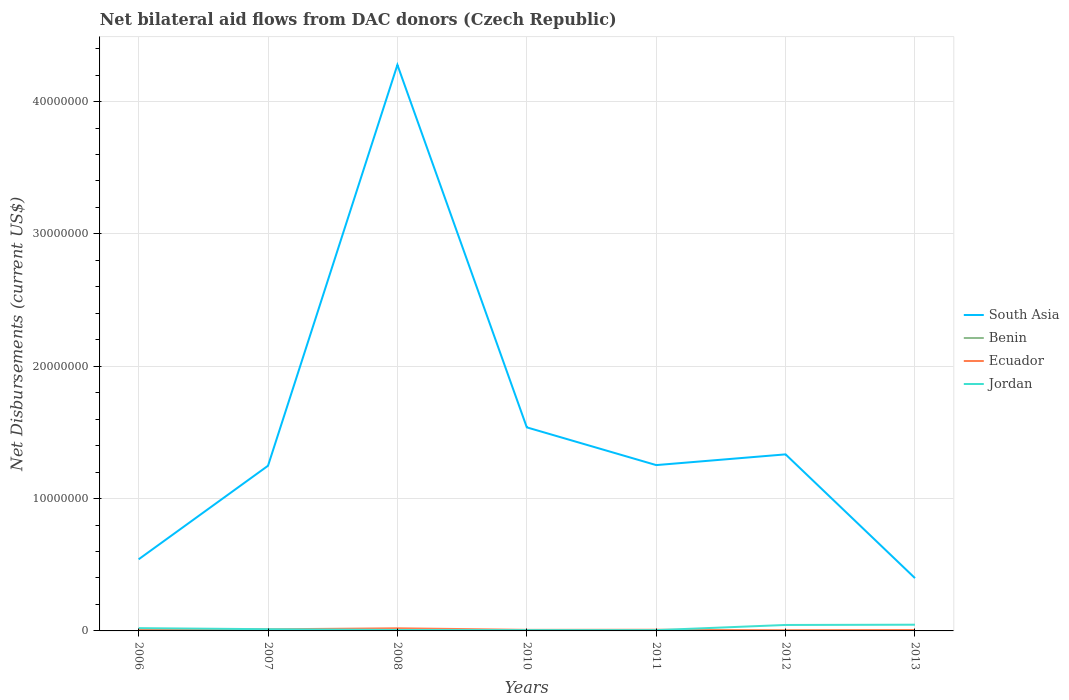Is the number of lines equal to the number of legend labels?
Keep it short and to the point. Yes. Across all years, what is the maximum net bilateral aid flows in Jordan?
Keep it short and to the point. 6.00e+04. In which year was the net bilateral aid flows in South Asia maximum?
Your response must be concise. 2013. What is the total net bilateral aid flows in South Asia in the graph?
Your answer should be compact. -9.97e+06. Is the net bilateral aid flows in South Asia strictly greater than the net bilateral aid flows in Ecuador over the years?
Provide a short and direct response. No. How many years are there in the graph?
Offer a terse response. 7. Where does the legend appear in the graph?
Give a very brief answer. Center right. How are the legend labels stacked?
Give a very brief answer. Vertical. What is the title of the graph?
Your answer should be compact. Net bilateral aid flows from DAC donors (Czech Republic). Does "Madagascar" appear as one of the legend labels in the graph?
Give a very brief answer. No. What is the label or title of the X-axis?
Your answer should be very brief. Years. What is the label or title of the Y-axis?
Offer a very short reply. Net Disbursements (current US$). What is the Net Disbursements (current US$) of South Asia in 2006?
Offer a terse response. 5.41e+06. What is the Net Disbursements (current US$) in Benin in 2006?
Keep it short and to the point. 10000. What is the Net Disbursements (current US$) in South Asia in 2007?
Provide a short and direct response. 1.25e+07. What is the Net Disbursements (current US$) of Benin in 2007?
Give a very brief answer. 10000. What is the Net Disbursements (current US$) in Jordan in 2007?
Offer a terse response. 1.30e+05. What is the Net Disbursements (current US$) in South Asia in 2008?
Give a very brief answer. 4.28e+07. What is the Net Disbursements (current US$) in Benin in 2008?
Your response must be concise. 4.00e+04. What is the Net Disbursements (current US$) of Ecuador in 2008?
Your answer should be compact. 2.00e+05. What is the Net Disbursements (current US$) in Jordan in 2008?
Your answer should be very brief. 7.00e+04. What is the Net Disbursements (current US$) of South Asia in 2010?
Provide a succinct answer. 1.54e+07. What is the Net Disbursements (current US$) of Ecuador in 2010?
Your answer should be compact. 8.00e+04. What is the Net Disbursements (current US$) in South Asia in 2011?
Your answer should be very brief. 1.25e+07. What is the Net Disbursements (current US$) in Benin in 2011?
Make the answer very short. 2.00e+04. What is the Net Disbursements (current US$) in South Asia in 2012?
Your answer should be very brief. 1.33e+07. What is the Net Disbursements (current US$) of Benin in 2012?
Your answer should be compact. 2.00e+04. What is the Net Disbursements (current US$) in Jordan in 2012?
Your response must be concise. 4.50e+05. What is the Net Disbursements (current US$) in South Asia in 2013?
Your answer should be compact. 3.99e+06. What is the Net Disbursements (current US$) in Benin in 2013?
Give a very brief answer. 3.00e+04. What is the Net Disbursements (current US$) in Jordan in 2013?
Give a very brief answer. 4.70e+05. Across all years, what is the maximum Net Disbursements (current US$) of South Asia?
Keep it short and to the point. 4.28e+07. Across all years, what is the maximum Net Disbursements (current US$) of Ecuador?
Provide a succinct answer. 2.00e+05. Across all years, what is the minimum Net Disbursements (current US$) of South Asia?
Make the answer very short. 3.99e+06. Across all years, what is the minimum Net Disbursements (current US$) of Ecuador?
Offer a very short reply. 5.00e+04. What is the total Net Disbursements (current US$) in South Asia in the graph?
Ensure brevity in your answer.  1.06e+08. What is the total Net Disbursements (current US$) of Ecuador in the graph?
Your answer should be very brief. 7.20e+05. What is the total Net Disbursements (current US$) in Jordan in the graph?
Keep it short and to the point. 1.45e+06. What is the difference between the Net Disbursements (current US$) in South Asia in 2006 and that in 2007?
Your response must be concise. -7.07e+06. What is the difference between the Net Disbursements (current US$) of South Asia in 2006 and that in 2008?
Your response must be concise. -3.74e+07. What is the difference between the Net Disbursements (current US$) of Benin in 2006 and that in 2008?
Offer a terse response. -3.00e+04. What is the difference between the Net Disbursements (current US$) in Ecuador in 2006 and that in 2008?
Provide a succinct answer. -9.00e+04. What is the difference between the Net Disbursements (current US$) in South Asia in 2006 and that in 2010?
Provide a short and direct response. -9.97e+06. What is the difference between the Net Disbursements (current US$) of Benin in 2006 and that in 2010?
Offer a terse response. -10000. What is the difference between the Net Disbursements (current US$) of Jordan in 2006 and that in 2010?
Give a very brief answer. 1.50e+05. What is the difference between the Net Disbursements (current US$) of South Asia in 2006 and that in 2011?
Ensure brevity in your answer.  -7.12e+06. What is the difference between the Net Disbursements (current US$) of Benin in 2006 and that in 2011?
Provide a short and direct response. -10000. What is the difference between the Net Disbursements (current US$) of Ecuador in 2006 and that in 2011?
Ensure brevity in your answer.  2.00e+04. What is the difference between the Net Disbursements (current US$) of South Asia in 2006 and that in 2012?
Make the answer very short. -7.93e+06. What is the difference between the Net Disbursements (current US$) in Benin in 2006 and that in 2012?
Your answer should be very brief. -10000. What is the difference between the Net Disbursements (current US$) in Jordan in 2006 and that in 2012?
Offer a very short reply. -2.40e+05. What is the difference between the Net Disbursements (current US$) in South Asia in 2006 and that in 2013?
Offer a terse response. 1.42e+06. What is the difference between the Net Disbursements (current US$) in Benin in 2006 and that in 2013?
Provide a succinct answer. -2.00e+04. What is the difference between the Net Disbursements (current US$) in Ecuador in 2006 and that in 2013?
Provide a succinct answer. 4.00e+04. What is the difference between the Net Disbursements (current US$) in South Asia in 2007 and that in 2008?
Your answer should be compact. -3.03e+07. What is the difference between the Net Disbursements (current US$) of Benin in 2007 and that in 2008?
Offer a terse response. -3.00e+04. What is the difference between the Net Disbursements (current US$) in Jordan in 2007 and that in 2008?
Your response must be concise. 6.00e+04. What is the difference between the Net Disbursements (current US$) of South Asia in 2007 and that in 2010?
Ensure brevity in your answer.  -2.90e+06. What is the difference between the Net Disbursements (current US$) in Jordan in 2007 and that in 2010?
Offer a terse response. 7.00e+04. What is the difference between the Net Disbursements (current US$) of Benin in 2007 and that in 2011?
Provide a short and direct response. -10000. What is the difference between the Net Disbursements (current US$) of Ecuador in 2007 and that in 2011?
Offer a very short reply. 3.00e+04. What is the difference between the Net Disbursements (current US$) of South Asia in 2007 and that in 2012?
Keep it short and to the point. -8.60e+05. What is the difference between the Net Disbursements (current US$) in Ecuador in 2007 and that in 2012?
Keep it short and to the point. 7.00e+04. What is the difference between the Net Disbursements (current US$) of Jordan in 2007 and that in 2012?
Provide a succinct answer. -3.20e+05. What is the difference between the Net Disbursements (current US$) of South Asia in 2007 and that in 2013?
Make the answer very short. 8.49e+06. What is the difference between the Net Disbursements (current US$) of South Asia in 2008 and that in 2010?
Provide a succinct answer. 2.74e+07. What is the difference between the Net Disbursements (current US$) in Benin in 2008 and that in 2010?
Ensure brevity in your answer.  2.00e+04. What is the difference between the Net Disbursements (current US$) of Ecuador in 2008 and that in 2010?
Give a very brief answer. 1.20e+05. What is the difference between the Net Disbursements (current US$) of Jordan in 2008 and that in 2010?
Keep it short and to the point. 10000. What is the difference between the Net Disbursements (current US$) of South Asia in 2008 and that in 2011?
Ensure brevity in your answer.  3.02e+07. What is the difference between the Net Disbursements (current US$) in Ecuador in 2008 and that in 2011?
Provide a short and direct response. 1.10e+05. What is the difference between the Net Disbursements (current US$) in South Asia in 2008 and that in 2012?
Give a very brief answer. 2.94e+07. What is the difference between the Net Disbursements (current US$) in Benin in 2008 and that in 2012?
Ensure brevity in your answer.  2.00e+04. What is the difference between the Net Disbursements (current US$) in Ecuador in 2008 and that in 2012?
Keep it short and to the point. 1.50e+05. What is the difference between the Net Disbursements (current US$) in Jordan in 2008 and that in 2012?
Keep it short and to the point. -3.80e+05. What is the difference between the Net Disbursements (current US$) of South Asia in 2008 and that in 2013?
Make the answer very short. 3.88e+07. What is the difference between the Net Disbursements (current US$) of Benin in 2008 and that in 2013?
Give a very brief answer. 10000. What is the difference between the Net Disbursements (current US$) of Ecuador in 2008 and that in 2013?
Make the answer very short. 1.30e+05. What is the difference between the Net Disbursements (current US$) of Jordan in 2008 and that in 2013?
Provide a short and direct response. -4.00e+05. What is the difference between the Net Disbursements (current US$) in South Asia in 2010 and that in 2011?
Your answer should be very brief. 2.85e+06. What is the difference between the Net Disbursements (current US$) in Benin in 2010 and that in 2011?
Make the answer very short. 0. What is the difference between the Net Disbursements (current US$) of Ecuador in 2010 and that in 2011?
Provide a short and direct response. -10000. What is the difference between the Net Disbursements (current US$) in Jordan in 2010 and that in 2011?
Offer a terse response. 0. What is the difference between the Net Disbursements (current US$) of South Asia in 2010 and that in 2012?
Your answer should be compact. 2.04e+06. What is the difference between the Net Disbursements (current US$) in Benin in 2010 and that in 2012?
Ensure brevity in your answer.  0. What is the difference between the Net Disbursements (current US$) in Ecuador in 2010 and that in 2012?
Your answer should be very brief. 3.00e+04. What is the difference between the Net Disbursements (current US$) of Jordan in 2010 and that in 2012?
Give a very brief answer. -3.90e+05. What is the difference between the Net Disbursements (current US$) of South Asia in 2010 and that in 2013?
Your answer should be very brief. 1.14e+07. What is the difference between the Net Disbursements (current US$) of Ecuador in 2010 and that in 2013?
Offer a terse response. 10000. What is the difference between the Net Disbursements (current US$) of Jordan in 2010 and that in 2013?
Ensure brevity in your answer.  -4.10e+05. What is the difference between the Net Disbursements (current US$) in South Asia in 2011 and that in 2012?
Offer a terse response. -8.10e+05. What is the difference between the Net Disbursements (current US$) in Jordan in 2011 and that in 2012?
Your answer should be very brief. -3.90e+05. What is the difference between the Net Disbursements (current US$) of South Asia in 2011 and that in 2013?
Ensure brevity in your answer.  8.54e+06. What is the difference between the Net Disbursements (current US$) of Jordan in 2011 and that in 2013?
Your response must be concise. -4.10e+05. What is the difference between the Net Disbursements (current US$) in South Asia in 2012 and that in 2013?
Keep it short and to the point. 9.35e+06. What is the difference between the Net Disbursements (current US$) in Ecuador in 2012 and that in 2013?
Provide a succinct answer. -2.00e+04. What is the difference between the Net Disbursements (current US$) of Jordan in 2012 and that in 2013?
Keep it short and to the point. -2.00e+04. What is the difference between the Net Disbursements (current US$) in South Asia in 2006 and the Net Disbursements (current US$) in Benin in 2007?
Make the answer very short. 5.40e+06. What is the difference between the Net Disbursements (current US$) in South Asia in 2006 and the Net Disbursements (current US$) in Ecuador in 2007?
Your answer should be compact. 5.29e+06. What is the difference between the Net Disbursements (current US$) in South Asia in 2006 and the Net Disbursements (current US$) in Jordan in 2007?
Give a very brief answer. 5.28e+06. What is the difference between the Net Disbursements (current US$) of Benin in 2006 and the Net Disbursements (current US$) of Jordan in 2007?
Give a very brief answer. -1.20e+05. What is the difference between the Net Disbursements (current US$) in South Asia in 2006 and the Net Disbursements (current US$) in Benin in 2008?
Ensure brevity in your answer.  5.37e+06. What is the difference between the Net Disbursements (current US$) of South Asia in 2006 and the Net Disbursements (current US$) of Ecuador in 2008?
Provide a succinct answer. 5.21e+06. What is the difference between the Net Disbursements (current US$) of South Asia in 2006 and the Net Disbursements (current US$) of Jordan in 2008?
Ensure brevity in your answer.  5.34e+06. What is the difference between the Net Disbursements (current US$) of Benin in 2006 and the Net Disbursements (current US$) of Jordan in 2008?
Provide a succinct answer. -6.00e+04. What is the difference between the Net Disbursements (current US$) of Ecuador in 2006 and the Net Disbursements (current US$) of Jordan in 2008?
Keep it short and to the point. 4.00e+04. What is the difference between the Net Disbursements (current US$) of South Asia in 2006 and the Net Disbursements (current US$) of Benin in 2010?
Give a very brief answer. 5.39e+06. What is the difference between the Net Disbursements (current US$) in South Asia in 2006 and the Net Disbursements (current US$) in Ecuador in 2010?
Keep it short and to the point. 5.33e+06. What is the difference between the Net Disbursements (current US$) in South Asia in 2006 and the Net Disbursements (current US$) in Jordan in 2010?
Offer a terse response. 5.35e+06. What is the difference between the Net Disbursements (current US$) of Benin in 2006 and the Net Disbursements (current US$) of Jordan in 2010?
Make the answer very short. -5.00e+04. What is the difference between the Net Disbursements (current US$) of South Asia in 2006 and the Net Disbursements (current US$) of Benin in 2011?
Keep it short and to the point. 5.39e+06. What is the difference between the Net Disbursements (current US$) in South Asia in 2006 and the Net Disbursements (current US$) in Ecuador in 2011?
Give a very brief answer. 5.32e+06. What is the difference between the Net Disbursements (current US$) of South Asia in 2006 and the Net Disbursements (current US$) of Jordan in 2011?
Your answer should be compact. 5.35e+06. What is the difference between the Net Disbursements (current US$) of Benin in 2006 and the Net Disbursements (current US$) of Jordan in 2011?
Provide a succinct answer. -5.00e+04. What is the difference between the Net Disbursements (current US$) in Ecuador in 2006 and the Net Disbursements (current US$) in Jordan in 2011?
Ensure brevity in your answer.  5.00e+04. What is the difference between the Net Disbursements (current US$) in South Asia in 2006 and the Net Disbursements (current US$) in Benin in 2012?
Your answer should be compact. 5.39e+06. What is the difference between the Net Disbursements (current US$) of South Asia in 2006 and the Net Disbursements (current US$) of Ecuador in 2012?
Keep it short and to the point. 5.36e+06. What is the difference between the Net Disbursements (current US$) in South Asia in 2006 and the Net Disbursements (current US$) in Jordan in 2012?
Offer a very short reply. 4.96e+06. What is the difference between the Net Disbursements (current US$) in Benin in 2006 and the Net Disbursements (current US$) in Ecuador in 2012?
Your answer should be compact. -4.00e+04. What is the difference between the Net Disbursements (current US$) of Benin in 2006 and the Net Disbursements (current US$) of Jordan in 2012?
Provide a succinct answer. -4.40e+05. What is the difference between the Net Disbursements (current US$) of South Asia in 2006 and the Net Disbursements (current US$) of Benin in 2013?
Your response must be concise. 5.38e+06. What is the difference between the Net Disbursements (current US$) of South Asia in 2006 and the Net Disbursements (current US$) of Ecuador in 2013?
Your answer should be very brief. 5.34e+06. What is the difference between the Net Disbursements (current US$) of South Asia in 2006 and the Net Disbursements (current US$) of Jordan in 2013?
Offer a very short reply. 4.94e+06. What is the difference between the Net Disbursements (current US$) in Benin in 2006 and the Net Disbursements (current US$) in Jordan in 2013?
Offer a very short reply. -4.60e+05. What is the difference between the Net Disbursements (current US$) of Ecuador in 2006 and the Net Disbursements (current US$) of Jordan in 2013?
Keep it short and to the point. -3.60e+05. What is the difference between the Net Disbursements (current US$) of South Asia in 2007 and the Net Disbursements (current US$) of Benin in 2008?
Your response must be concise. 1.24e+07. What is the difference between the Net Disbursements (current US$) in South Asia in 2007 and the Net Disbursements (current US$) in Ecuador in 2008?
Ensure brevity in your answer.  1.23e+07. What is the difference between the Net Disbursements (current US$) of South Asia in 2007 and the Net Disbursements (current US$) of Jordan in 2008?
Give a very brief answer. 1.24e+07. What is the difference between the Net Disbursements (current US$) of Benin in 2007 and the Net Disbursements (current US$) of Ecuador in 2008?
Offer a terse response. -1.90e+05. What is the difference between the Net Disbursements (current US$) of Benin in 2007 and the Net Disbursements (current US$) of Jordan in 2008?
Your answer should be compact. -6.00e+04. What is the difference between the Net Disbursements (current US$) of Ecuador in 2007 and the Net Disbursements (current US$) of Jordan in 2008?
Offer a very short reply. 5.00e+04. What is the difference between the Net Disbursements (current US$) of South Asia in 2007 and the Net Disbursements (current US$) of Benin in 2010?
Offer a very short reply. 1.25e+07. What is the difference between the Net Disbursements (current US$) in South Asia in 2007 and the Net Disbursements (current US$) in Ecuador in 2010?
Ensure brevity in your answer.  1.24e+07. What is the difference between the Net Disbursements (current US$) of South Asia in 2007 and the Net Disbursements (current US$) of Jordan in 2010?
Make the answer very short. 1.24e+07. What is the difference between the Net Disbursements (current US$) in Benin in 2007 and the Net Disbursements (current US$) in Ecuador in 2010?
Give a very brief answer. -7.00e+04. What is the difference between the Net Disbursements (current US$) of Benin in 2007 and the Net Disbursements (current US$) of Jordan in 2010?
Your response must be concise. -5.00e+04. What is the difference between the Net Disbursements (current US$) of South Asia in 2007 and the Net Disbursements (current US$) of Benin in 2011?
Offer a terse response. 1.25e+07. What is the difference between the Net Disbursements (current US$) in South Asia in 2007 and the Net Disbursements (current US$) in Ecuador in 2011?
Give a very brief answer. 1.24e+07. What is the difference between the Net Disbursements (current US$) in South Asia in 2007 and the Net Disbursements (current US$) in Jordan in 2011?
Keep it short and to the point. 1.24e+07. What is the difference between the Net Disbursements (current US$) in Benin in 2007 and the Net Disbursements (current US$) in Ecuador in 2011?
Provide a short and direct response. -8.00e+04. What is the difference between the Net Disbursements (current US$) in Ecuador in 2007 and the Net Disbursements (current US$) in Jordan in 2011?
Provide a short and direct response. 6.00e+04. What is the difference between the Net Disbursements (current US$) of South Asia in 2007 and the Net Disbursements (current US$) of Benin in 2012?
Offer a terse response. 1.25e+07. What is the difference between the Net Disbursements (current US$) in South Asia in 2007 and the Net Disbursements (current US$) in Ecuador in 2012?
Offer a very short reply. 1.24e+07. What is the difference between the Net Disbursements (current US$) in South Asia in 2007 and the Net Disbursements (current US$) in Jordan in 2012?
Provide a short and direct response. 1.20e+07. What is the difference between the Net Disbursements (current US$) of Benin in 2007 and the Net Disbursements (current US$) of Jordan in 2012?
Keep it short and to the point. -4.40e+05. What is the difference between the Net Disbursements (current US$) of Ecuador in 2007 and the Net Disbursements (current US$) of Jordan in 2012?
Give a very brief answer. -3.30e+05. What is the difference between the Net Disbursements (current US$) in South Asia in 2007 and the Net Disbursements (current US$) in Benin in 2013?
Give a very brief answer. 1.24e+07. What is the difference between the Net Disbursements (current US$) of South Asia in 2007 and the Net Disbursements (current US$) of Ecuador in 2013?
Ensure brevity in your answer.  1.24e+07. What is the difference between the Net Disbursements (current US$) in South Asia in 2007 and the Net Disbursements (current US$) in Jordan in 2013?
Provide a short and direct response. 1.20e+07. What is the difference between the Net Disbursements (current US$) of Benin in 2007 and the Net Disbursements (current US$) of Jordan in 2013?
Provide a succinct answer. -4.60e+05. What is the difference between the Net Disbursements (current US$) in Ecuador in 2007 and the Net Disbursements (current US$) in Jordan in 2013?
Your response must be concise. -3.50e+05. What is the difference between the Net Disbursements (current US$) in South Asia in 2008 and the Net Disbursements (current US$) in Benin in 2010?
Offer a terse response. 4.28e+07. What is the difference between the Net Disbursements (current US$) in South Asia in 2008 and the Net Disbursements (current US$) in Ecuador in 2010?
Your answer should be compact. 4.27e+07. What is the difference between the Net Disbursements (current US$) in South Asia in 2008 and the Net Disbursements (current US$) in Jordan in 2010?
Offer a very short reply. 4.27e+07. What is the difference between the Net Disbursements (current US$) of Benin in 2008 and the Net Disbursements (current US$) of Ecuador in 2010?
Offer a very short reply. -4.00e+04. What is the difference between the Net Disbursements (current US$) of South Asia in 2008 and the Net Disbursements (current US$) of Benin in 2011?
Provide a short and direct response. 4.28e+07. What is the difference between the Net Disbursements (current US$) in South Asia in 2008 and the Net Disbursements (current US$) in Ecuador in 2011?
Your response must be concise. 4.27e+07. What is the difference between the Net Disbursements (current US$) of South Asia in 2008 and the Net Disbursements (current US$) of Jordan in 2011?
Ensure brevity in your answer.  4.27e+07. What is the difference between the Net Disbursements (current US$) in Ecuador in 2008 and the Net Disbursements (current US$) in Jordan in 2011?
Provide a short and direct response. 1.40e+05. What is the difference between the Net Disbursements (current US$) of South Asia in 2008 and the Net Disbursements (current US$) of Benin in 2012?
Make the answer very short. 4.28e+07. What is the difference between the Net Disbursements (current US$) in South Asia in 2008 and the Net Disbursements (current US$) in Ecuador in 2012?
Give a very brief answer. 4.27e+07. What is the difference between the Net Disbursements (current US$) of South Asia in 2008 and the Net Disbursements (current US$) of Jordan in 2012?
Offer a very short reply. 4.23e+07. What is the difference between the Net Disbursements (current US$) in Benin in 2008 and the Net Disbursements (current US$) in Ecuador in 2012?
Ensure brevity in your answer.  -10000. What is the difference between the Net Disbursements (current US$) in Benin in 2008 and the Net Disbursements (current US$) in Jordan in 2012?
Give a very brief answer. -4.10e+05. What is the difference between the Net Disbursements (current US$) in Ecuador in 2008 and the Net Disbursements (current US$) in Jordan in 2012?
Provide a succinct answer. -2.50e+05. What is the difference between the Net Disbursements (current US$) of South Asia in 2008 and the Net Disbursements (current US$) of Benin in 2013?
Give a very brief answer. 4.27e+07. What is the difference between the Net Disbursements (current US$) in South Asia in 2008 and the Net Disbursements (current US$) in Ecuador in 2013?
Ensure brevity in your answer.  4.27e+07. What is the difference between the Net Disbursements (current US$) in South Asia in 2008 and the Net Disbursements (current US$) in Jordan in 2013?
Provide a succinct answer. 4.23e+07. What is the difference between the Net Disbursements (current US$) in Benin in 2008 and the Net Disbursements (current US$) in Jordan in 2013?
Keep it short and to the point. -4.30e+05. What is the difference between the Net Disbursements (current US$) in Ecuador in 2008 and the Net Disbursements (current US$) in Jordan in 2013?
Your answer should be compact. -2.70e+05. What is the difference between the Net Disbursements (current US$) in South Asia in 2010 and the Net Disbursements (current US$) in Benin in 2011?
Provide a short and direct response. 1.54e+07. What is the difference between the Net Disbursements (current US$) of South Asia in 2010 and the Net Disbursements (current US$) of Ecuador in 2011?
Keep it short and to the point. 1.53e+07. What is the difference between the Net Disbursements (current US$) in South Asia in 2010 and the Net Disbursements (current US$) in Jordan in 2011?
Keep it short and to the point. 1.53e+07. What is the difference between the Net Disbursements (current US$) of South Asia in 2010 and the Net Disbursements (current US$) of Benin in 2012?
Ensure brevity in your answer.  1.54e+07. What is the difference between the Net Disbursements (current US$) in South Asia in 2010 and the Net Disbursements (current US$) in Ecuador in 2012?
Your response must be concise. 1.53e+07. What is the difference between the Net Disbursements (current US$) in South Asia in 2010 and the Net Disbursements (current US$) in Jordan in 2012?
Make the answer very short. 1.49e+07. What is the difference between the Net Disbursements (current US$) of Benin in 2010 and the Net Disbursements (current US$) of Jordan in 2012?
Provide a short and direct response. -4.30e+05. What is the difference between the Net Disbursements (current US$) of Ecuador in 2010 and the Net Disbursements (current US$) of Jordan in 2012?
Provide a succinct answer. -3.70e+05. What is the difference between the Net Disbursements (current US$) in South Asia in 2010 and the Net Disbursements (current US$) in Benin in 2013?
Ensure brevity in your answer.  1.54e+07. What is the difference between the Net Disbursements (current US$) of South Asia in 2010 and the Net Disbursements (current US$) of Ecuador in 2013?
Your answer should be compact. 1.53e+07. What is the difference between the Net Disbursements (current US$) in South Asia in 2010 and the Net Disbursements (current US$) in Jordan in 2013?
Provide a succinct answer. 1.49e+07. What is the difference between the Net Disbursements (current US$) in Benin in 2010 and the Net Disbursements (current US$) in Jordan in 2013?
Your answer should be compact. -4.50e+05. What is the difference between the Net Disbursements (current US$) of Ecuador in 2010 and the Net Disbursements (current US$) of Jordan in 2013?
Offer a very short reply. -3.90e+05. What is the difference between the Net Disbursements (current US$) of South Asia in 2011 and the Net Disbursements (current US$) of Benin in 2012?
Give a very brief answer. 1.25e+07. What is the difference between the Net Disbursements (current US$) of South Asia in 2011 and the Net Disbursements (current US$) of Ecuador in 2012?
Provide a succinct answer. 1.25e+07. What is the difference between the Net Disbursements (current US$) of South Asia in 2011 and the Net Disbursements (current US$) of Jordan in 2012?
Provide a short and direct response. 1.21e+07. What is the difference between the Net Disbursements (current US$) in Benin in 2011 and the Net Disbursements (current US$) in Jordan in 2012?
Give a very brief answer. -4.30e+05. What is the difference between the Net Disbursements (current US$) of Ecuador in 2011 and the Net Disbursements (current US$) of Jordan in 2012?
Your response must be concise. -3.60e+05. What is the difference between the Net Disbursements (current US$) in South Asia in 2011 and the Net Disbursements (current US$) in Benin in 2013?
Your response must be concise. 1.25e+07. What is the difference between the Net Disbursements (current US$) of South Asia in 2011 and the Net Disbursements (current US$) of Ecuador in 2013?
Offer a terse response. 1.25e+07. What is the difference between the Net Disbursements (current US$) of South Asia in 2011 and the Net Disbursements (current US$) of Jordan in 2013?
Ensure brevity in your answer.  1.21e+07. What is the difference between the Net Disbursements (current US$) of Benin in 2011 and the Net Disbursements (current US$) of Ecuador in 2013?
Provide a short and direct response. -5.00e+04. What is the difference between the Net Disbursements (current US$) of Benin in 2011 and the Net Disbursements (current US$) of Jordan in 2013?
Provide a short and direct response. -4.50e+05. What is the difference between the Net Disbursements (current US$) of Ecuador in 2011 and the Net Disbursements (current US$) of Jordan in 2013?
Make the answer very short. -3.80e+05. What is the difference between the Net Disbursements (current US$) in South Asia in 2012 and the Net Disbursements (current US$) in Benin in 2013?
Offer a terse response. 1.33e+07. What is the difference between the Net Disbursements (current US$) in South Asia in 2012 and the Net Disbursements (current US$) in Ecuador in 2013?
Your answer should be compact. 1.33e+07. What is the difference between the Net Disbursements (current US$) of South Asia in 2012 and the Net Disbursements (current US$) of Jordan in 2013?
Make the answer very short. 1.29e+07. What is the difference between the Net Disbursements (current US$) of Benin in 2012 and the Net Disbursements (current US$) of Ecuador in 2013?
Give a very brief answer. -5.00e+04. What is the difference between the Net Disbursements (current US$) in Benin in 2012 and the Net Disbursements (current US$) in Jordan in 2013?
Provide a succinct answer. -4.50e+05. What is the difference between the Net Disbursements (current US$) of Ecuador in 2012 and the Net Disbursements (current US$) of Jordan in 2013?
Your answer should be compact. -4.20e+05. What is the average Net Disbursements (current US$) of South Asia per year?
Give a very brief answer. 1.51e+07. What is the average Net Disbursements (current US$) of Benin per year?
Your answer should be compact. 2.14e+04. What is the average Net Disbursements (current US$) of Ecuador per year?
Offer a terse response. 1.03e+05. What is the average Net Disbursements (current US$) of Jordan per year?
Provide a short and direct response. 2.07e+05. In the year 2006, what is the difference between the Net Disbursements (current US$) of South Asia and Net Disbursements (current US$) of Benin?
Give a very brief answer. 5.40e+06. In the year 2006, what is the difference between the Net Disbursements (current US$) in South Asia and Net Disbursements (current US$) in Ecuador?
Your response must be concise. 5.30e+06. In the year 2006, what is the difference between the Net Disbursements (current US$) in South Asia and Net Disbursements (current US$) in Jordan?
Your answer should be very brief. 5.20e+06. In the year 2006, what is the difference between the Net Disbursements (current US$) of Benin and Net Disbursements (current US$) of Jordan?
Ensure brevity in your answer.  -2.00e+05. In the year 2007, what is the difference between the Net Disbursements (current US$) of South Asia and Net Disbursements (current US$) of Benin?
Keep it short and to the point. 1.25e+07. In the year 2007, what is the difference between the Net Disbursements (current US$) in South Asia and Net Disbursements (current US$) in Ecuador?
Your response must be concise. 1.24e+07. In the year 2007, what is the difference between the Net Disbursements (current US$) in South Asia and Net Disbursements (current US$) in Jordan?
Your answer should be very brief. 1.24e+07. In the year 2007, what is the difference between the Net Disbursements (current US$) in Benin and Net Disbursements (current US$) in Ecuador?
Offer a very short reply. -1.10e+05. In the year 2008, what is the difference between the Net Disbursements (current US$) of South Asia and Net Disbursements (current US$) of Benin?
Ensure brevity in your answer.  4.27e+07. In the year 2008, what is the difference between the Net Disbursements (current US$) in South Asia and Net Disbursements (current US$) in Ecuador?
Your answer should be very brief. 4.26e+07. In the year 2008, what is the difference between the Net Disbursements (current US$) in South Asia and Net Disbursements (current US$) in Jordan?
Your response must be concise. 4.27e+07. In the year 2008, what is the difference between the Net Disbursements (current US$) in Benin and Net Disbursements (current US$) in Ecuador?
Offer a very short reply. -1.60e+05. In the year 2008, what is the difference between the Net Disbursements (current US$) of Ecuador and Net Disbursements (current US$) of Jordan?
Give a very brief answer. 1.30e+05. In the year 2010, what is the difference between the Net Disbursements (current US$) in South Asia and Net Disbursements (current US$) in Benin?
Make the answer very short. 1.54e+07. In the year 2010, what is the difference between the Net Disbursements (current US$) in South Asia and Net Disbursements (current US$) in Ecuador?
Keep it short and to the point. 1.53e+07. In the year 2010, what is the difference between the Net Disbursements (current US$) of South Asia and Net Disbursements (current US$) of Jordan?
Make the answer very short. 1.53e+07. In the year 2010, what is the difference between the Net Disbursements (current US$) in Benin and Net Disbursements (current US$) in Ecuador?
Your answer should be compact. -6.00e+04. In the year 2010, what is the difference between the Net Disbursements (current US$) of Benin and Net Disbursements (current US$) of Jordan?
Provide a succinct answer. -4.00e+04. In the year 2010, what is the difference between the Net Disbursements (current US$) in Ecuador and Net Disbursements (current US$) in Jordan?
Make the answer very short. 2.00e+04. In the year 2011, what is the difference between the Net Disbursements (current US$) in South Asia and Net Disbursements (current US$) in Benin?
Offer a terse response. 1.25e+07. In the year 2011, what is the difference between the Net Disbursements (current US$) in South Asia and Net Disbursements (current US$) in Ecuador?
Offer a terse response. 1.24e+07. In the year 2011, what is the difference between the Net Disbursements (current US$) of South Asia and Net Disbursements (current US$) of Jordan?
Ensure brevity in your answer.  1.25e+07. In the year 2011, what is the difference between the Net Disbursements (current US$) of Ecuador and Net Disbursements (current US$) of Jordan?
Provide a short and direct response. 3.00e+04. In the year 2012, what is the difference between the Net Disbursements (current US$) in South Asia and Net Disbursements (current US$) in Benin?
Offer a terse response. 1.33e+07. In the year 2012, what is the difference between the Net Disbursements (current US$) in South Asia and Net Disbursements (current US$) in Ecuador?
Provide a short and direct response. 1.33e+07. In the year 2012, what is the difference between the Net Disbursements (current US$) in South Asia and Net Disbursements (current US$) in Jordan?
Give a very brief answer. 1.29e+07. In the year 2012, what is the difference between the Net Disbursements (current US$) in Benin and Net Disbursements (current US$) in Ecuador?
Offer a terse response. -3.00e+04. In the year 2012, what is the difference between the Net Disbursements (current US$) in Benin and Net Disbursements (current US$) in Jordan?
Give a very brief answer. -4.30e+05. In the year 2012, what is the difference between the Net Disbursements (current US$) in Ecuador and Net Disbursements (current US$) in Jordan?
Keep it short and to the point. -4.00e+05. In the year 2013, what is the difference between the Net Disbursements (current US$) of South Asia and Net Disbursements (current US$) of Benin?
Give a very brief answer. 3.96e+06. In the year 2013, what is the difference between the Net Disbursements (current US$) in South Asia and Net Disbursements (current US$) in Ecuador?
Give a very brief answer. 3.92e+06. In the year 2013, what is the difference between the Net Disbursements (current US$) of South Asia and Net Disbursements (current US$) of Jordan?
Make the answer very short. 3.52e+06. In the year 2013, what is the difference between the Net Disbursements (current US$) in Benin and Net Disbursements (current US$) in Jordan?
Make the answer very short. -4.40e+05. In the year 2013, what is the difference between the Net Disbursements (current US$) in Ecuador and Net Disbursements (current US$) in Jordan?
Offer a terse response. -4.00e+05. What is the ratio of the Net Disbursements (current US$) of South Asia in 2006 to that in 2007?
Your response must be concise. 0.43. What is the ratio of the Net Disbursements (current US$) in Benin in 2006 to that in 2007?
Offer a terse response. 1. What is the ratio of the Net Disbursements (current US$) of Ecuador in 2006 to that in 2007?
Provide a short and direct response. 0.92. What is the ratio of the Net Disbursements (current US$) of Jordan in 2006 to that in 2007?
Provide a short and direct response. 1.62. What is the ratio of the Net Disbursements (current US$) of South Asia in 2006 to that in 2008?
Your response must be concise. 0.13. What is the ratio of the Net Disbursements (current US$) of Ecuador in 2006 to that in 2008?
Keep it short and to the point. 0.55. What is the ratio of the Net Disbursements (current US$) in Jordan in 2006 to that in 2008?
Ensure brevity in your answer.  3. What is the ratio of the Net Disbursements (current US$) in South Asia in 2006 to that in 2010?
Give a very brief answer. 0.35. What is the ratio of the Net Disbursements (current US$) in Ecuador in 2006 to that in 2010?
Provide a succinct answer. 1.38. What is the ratio of the Net Disbursements (current US$) in Jordan in 2006 to that in 2010?
Provide a succinct answer. 3.5. What is the ratio of the Net Disbursements (current US$) of South Asia in 2006 to that in 2011?
Provide a succinct answer. 0.43. What is the ratio of the Net Disbursements (current US$) in Ecuador in 2006 to that in 2011?
Make the answer very short. 1.22. What is the ratio of the Net Disbursements (current US$) of South Asia in 2006 to that in 2012?
Your answer should be compact. 0.41. What is the ratio of the Net Disbursements (current US$) in Ecuador in 2006 to that in 2012?
Provide a short and direct response. 2.2. What is the ratio of the Net Disbursements (current US$) of Jordan in 2006 to that in 2012?
Provide a short and direct response. 0.47. What is the ratio of the Net Disbursements (current US$) of South Asia in 2006 to that in 2013?
Your answer should be compact. 1.36. What is the ratio of the Net Disbursements (current US$) in Benin in 2006 to that in 2013?
Your answer should be very brief. 0.33. What is the ratio of the Net Disbursements (current US$) in Ecuador in 2006 to that in 2013?
Offer a terse response. 1.57. What is the ratio of the Net Disbursements (current US$) in Jordan in 2006 to that in 2013?
Ensure brevity in your answer.  0.45. What is the ratio of the Net Disbursements (current US$) in South Asia in 2007 to that in 2008?
Offer a very short reply. 0.29. What is the ratio of the Net Disbursements (current US$) in Benin in 2007 to that in 2008?
Your answer should be compact. 0.25. What is the ratio of the Net Disbursements (current US$) of Ecuador in 2007 to that in 2008?
Your answer should be very brief. 0.6. What is the ratio of the Net Disbursements (current US$) of Jordan in 2007 to that in 2008?
Make the answer very short. 1.86. What is the ratio of the Net Disbursements (current US$) of South Asia in 2007 to that in 2010?
Give a very brief answer. 0.81. What is the ratio of the Net Disbursements (current US$) of Benin in 2007 to that in 2010?
Provide a short and direct response. 0.5. What is the ratio of the Net Disbursements (current US$) of Ecuador in 2007 to that in 2010?
Keep it short and to the point. 1.5. What is the ratio of the Net Disbursements (current US$) of Jordan in 2007 to that in 2010?
Your response must be concise. 2.17. What is the ratio of the Net Disbursements (current US$) of South Asia in 2007 to that in 2011?
Provide a short and direct response. 1. What is the ratio of the Net Disbursements (current US$) of Benin in 2007 to that in 2011?
Provide a succinct answer. 0.5. What is the ratio of the Net Disbursements (current US$) of Jordan in 2007 to that in 2011?
Your response must be concise. 2.17. What is the ratio of the Net Disbursements (current US$) of South Asia in 2007 to that in 2012?
Provide a short and direct response. 0.94. What is the ratio of the Net Disbursements (current US$) in Ecuador in 2007 to that in 2012?
Your answer should be compact. 2.4. What is the ratio of the Net Disbursements (current US$) of Jordan in 2007 to that in 2012?
Offer a terse response. 0.29. What is the ratio of the Net Disbursements (current US$) of South Asia in 2007 to that in 2013?
Offer a very short reply. 3.13. What is the ratio of the Net Disbursements (current US$) in Benin in 2007 to that in 2013?
Offer a very short reply. 0.33. What is the ratio of the Net Disbursements (current US$) in Ecuador in 2007 to that in 2013?
Keep it short and to the point. 1.71. What is the ratio of the Net Disbursements (current US$) in Jordan in 2007 to that in 2013?
Offer a terse response. 0.28. What is the ratio of the Net Disbursements (current US$) of South Asia in 2008 to that in 2010?
Offer a very short reply. 2.78. What is the ratio of the Net Disbursements (current US$) in South Asia in 2008 to that in 2011?
Your answer should be compact. 3.41. What is the ratio of the Net Disbursements (current US$) of Benin in 2008 to that in 2011?
Give a very brief answer. 2. What is the ratio of the Net Disbursements (current US$) in Ecuador in 2008 to that in 2011?
Give a very brief answer. 2.22. What is the ratio of the Net Disbursements (current US$) in Jordan in 2008 to that in 2011?
Offer a very short reply. 1.17. What is the ratio of the Net Disbursements (current US$) in South Asia in 2008 to that in 2012?
Provide a short and direct response. 3.21. What is the ratio of the Net Disbursements (current US$) of Benin in 2008 to that in 2012?
Your response must be concise. 2. What is the ratio of the Net Disbursements (current US$) of Jordan in 2008 to that in 2012?
Offer a very short reply. 0.16. What is the ratio of the Net Disbursements (current US$) of South Asia in 2008 to that in 2013?
Offer a very short reply. 10.72. What is the ratio of the Net Disbursements (current US$) in Ecuador in 2008 to that in 2013?
Make the answer very short. 2.86. What is the ratio of the Net Disbursements (current US$) in Jordan in 2008 to that in 2013?
Provide a short and direct response. 0.15. What is the ratio of the Net Disbursements (current US$) of South Asia in 2010 to that in 2011?
Provide a short and direct response. 1.23. What is the ratio of the Net Disbursements (current US$) in South Asia in 2010 to that in 2012?
Ensure brevity in your answer.  1.15. What is the ratio of the Net Disbursements (current US$) in Benin in 2010 to that in 2012?
Offer a very short reply. 1. What is the ratio of the Net Disbursements (current US$) of Ecuador in 2010 to that in 2012?
Offer a terse response. 1.6. What is the ratio of the Net Disbursements (current US$) of Jordan in 2010 to that in 2012?
Provide a short and direct response. 0.13. What is the ratio of the Net Disbursements (current US$) in South Asia in 2010 to that in 2013?
Provide a short and direct response. 3.85. What is the ratio of the Net Disbursements (current US$) in Benin in 2010 to that in 2013?
Give a very brief answer. 0.67. What is the ratio of the Net Disbursements (current US$) in Ecuador in 2010 to that in 2013?
Offer a terse response. 1.14. What is the ratio of the Net Disbursements (current US$) in Jordan in 2010 to that in 2013?
Keep it short and to the point. 0.13. What is the ratio of the Net Disbursements (current US$) of South Asia in 2011 to that in 2012?
Provide a short and direct response. 0.94. What is the ratio of the Net Disbursements (current US$) in Benin in 2011 to that in 2012?
Provide a succinct answer. 1. What is the ratio of the Net Disbursements (current US$) in Jordan in 2011 to that in 2012?
Your response must be concise. 0.13. What is the ratio of the Net Disbursements (current US$) in South Asia in 2011 to that in 2013?
Ensure brevity in your answer.  3.14. What is the ratio of the Net Disbursements (current US$) in Jordan in 2011 to that in 2013?
Your answer should be very brief. 0.13. What is the ratio of the Net Disbursements (current US$) of South Asia in 2012 to that in 2013?
Ensure brevity in your answer.  3.34. What is the ratio of the Net Disbursements (current US$) of Ecuador in 2012 to that in 2013?
Ensure brevity in your answer.  0.71. What is the ratio of the Net Disbursements (current US$) of Jordan in 2012 to that in 2013?
Give a very brief answer. 0.96. What is the difference between the highest and the second highest Net Disbursements (current US$) of South Asia?
Offer a very short reply. 2.74e+07. What is the difference between the highest and the second highest Net Disbursements (current US$) of Ecuador?
Keep it short and to the point. 8.00e+04. What is the difference between the highest and the second highest Net Disbursements (current US$) of Jordan?
Your answer should be very brief. 2.00e+04. What is the difference between the highest and the lowest Net Disbursements (current US$) of South Asia?
Your answer should be compact. 3.88e+07. What is the difference between the highest and the lowest Net Disbursements (current US$) of Benin?
Your answer should be compact. 3.00e+04. What is the difference between the highest and the lowest Net Disbursements (current US$) in Ecuador?
Your answer should be very brief. 1.50e+05. What is the difference between the highest and the lowest Net Disbursements (current US$) of Jordan?
Your response must be concise. 4.10e+05. 